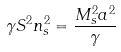Convert formula to latex. <formula><loc_0><loc_0><loc_500><loc_500>\gamma S ^ { 2 } n _ { s } ^ { 2 } = \frac { M _ { s } ^ { 2 } a ^ { 2 } } { \gamma }</formula> 